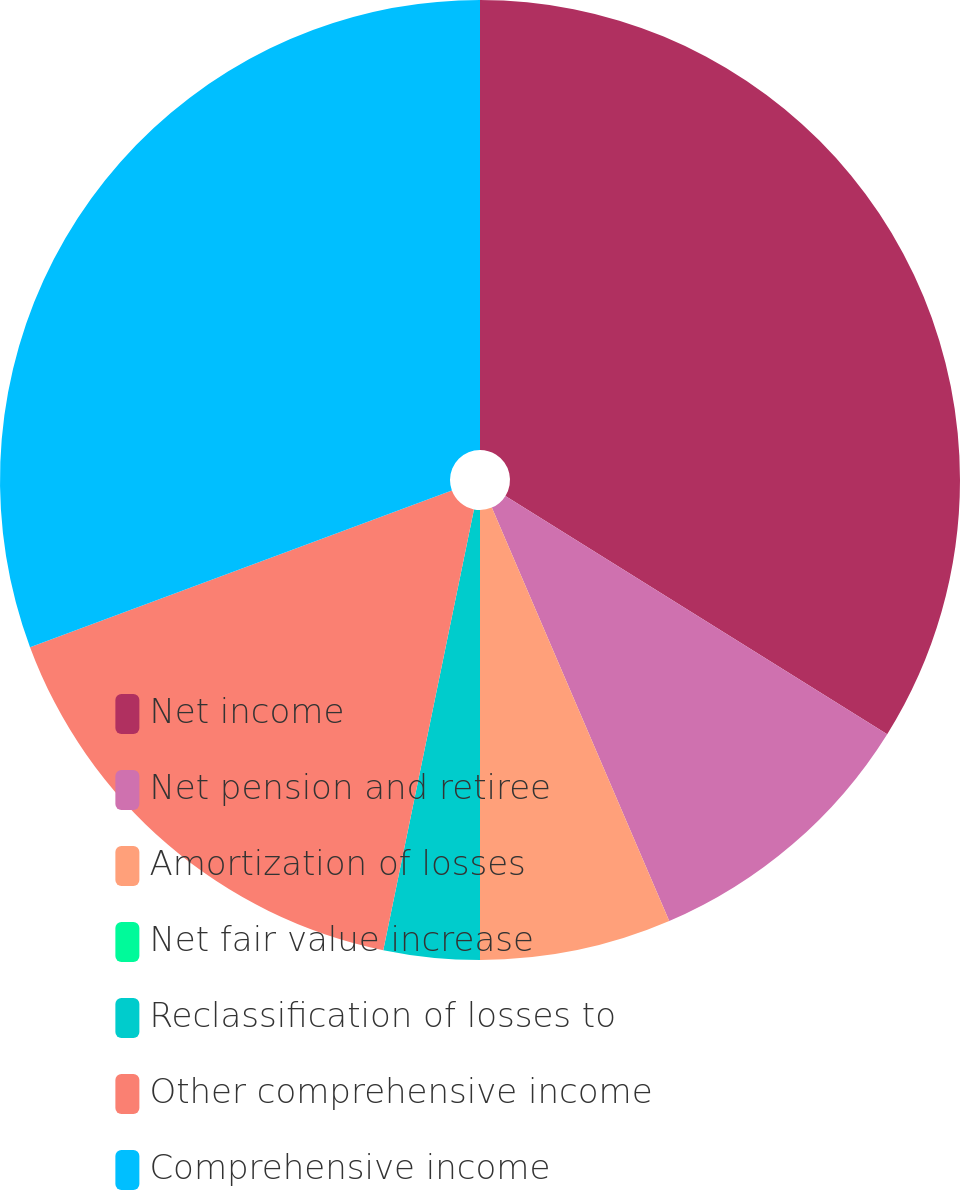<chart> <loc_0><loc_0><loc_500><loc_500><pie_chart><fcel>Net income<fcel>Net pension and retiree<fcel>Amortization of losses<fcel>Net fair value increase<fcel>Reclassification of losses to<fcel>Other comprehensive income<fcel>Comprehensive income<nl><fcel>33.88%<fcel>9.67%<fcel>6.45%<fcel>0.0%<fcel>3.23%<fcel>16.11%<fcel>30.66%<nl></chart> 